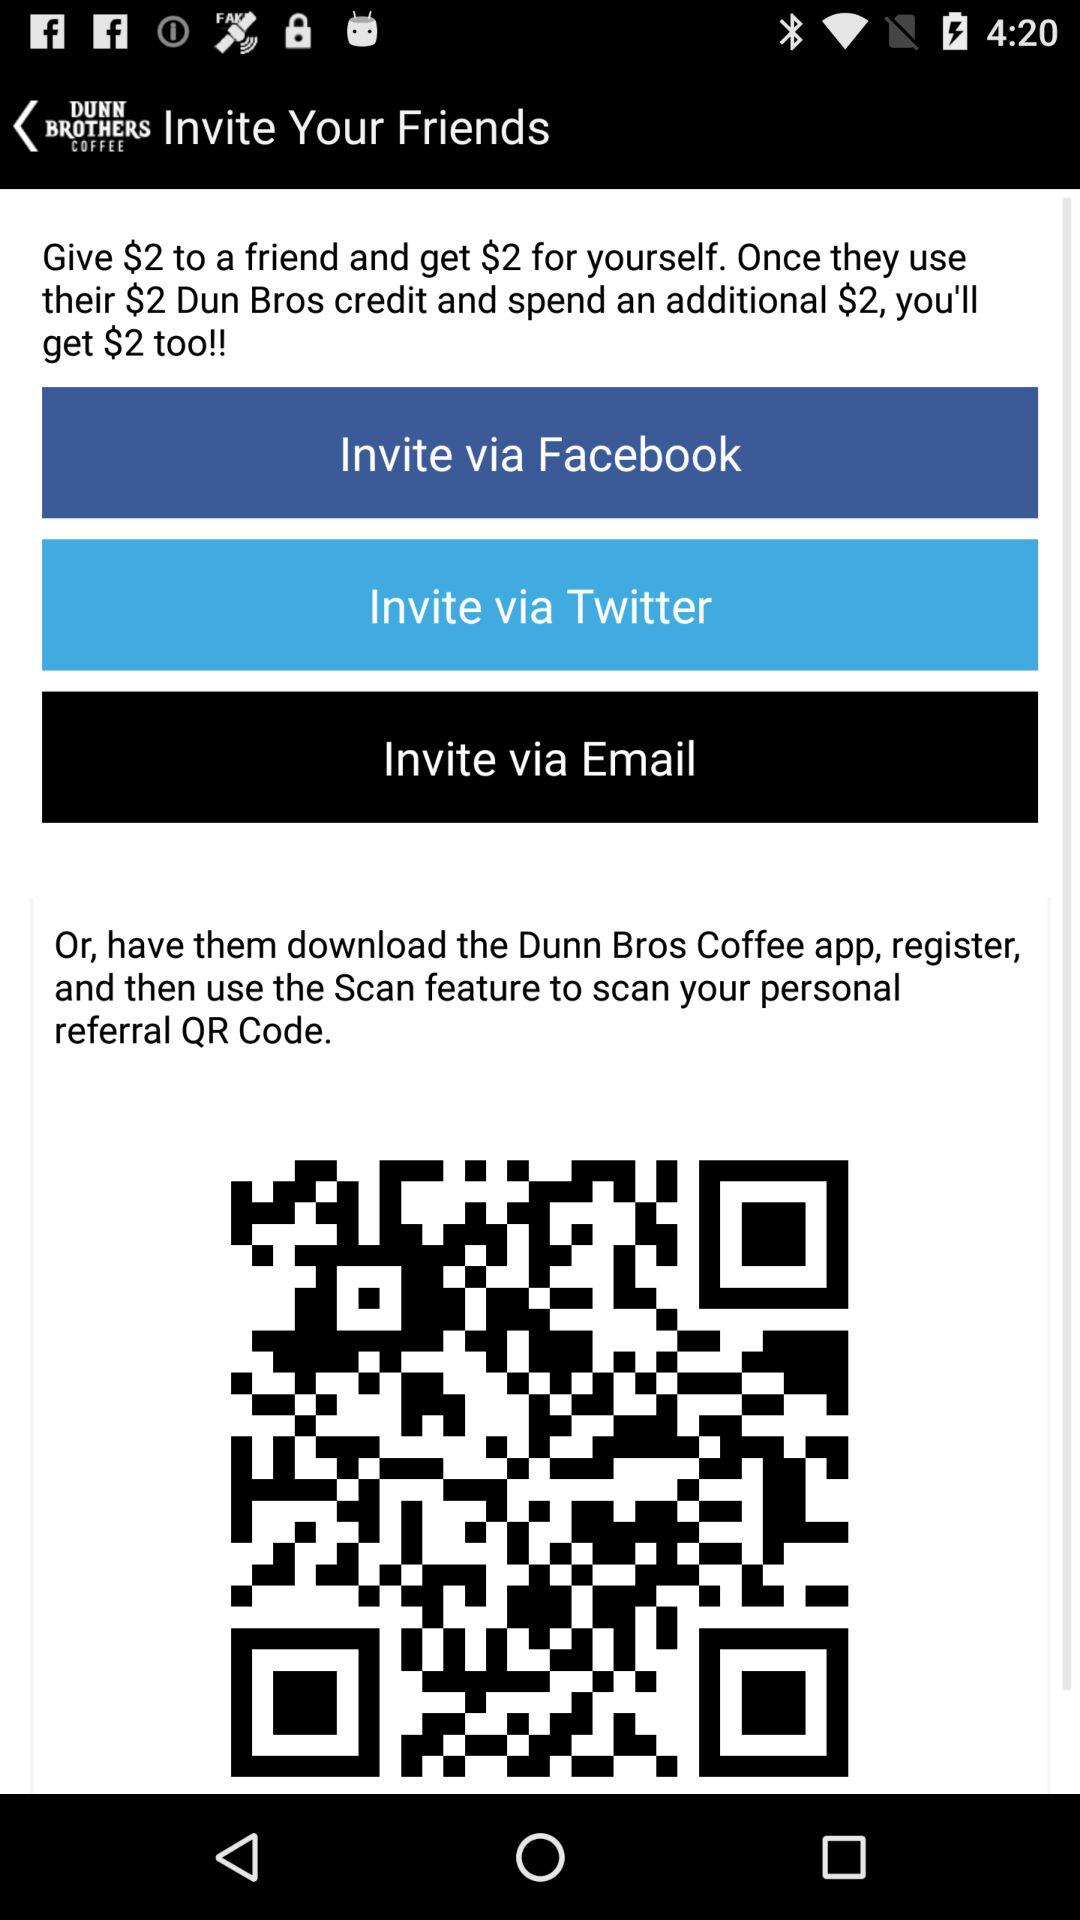What is the name of the application? The name of the application is "Dunn Brothers Coffee". 